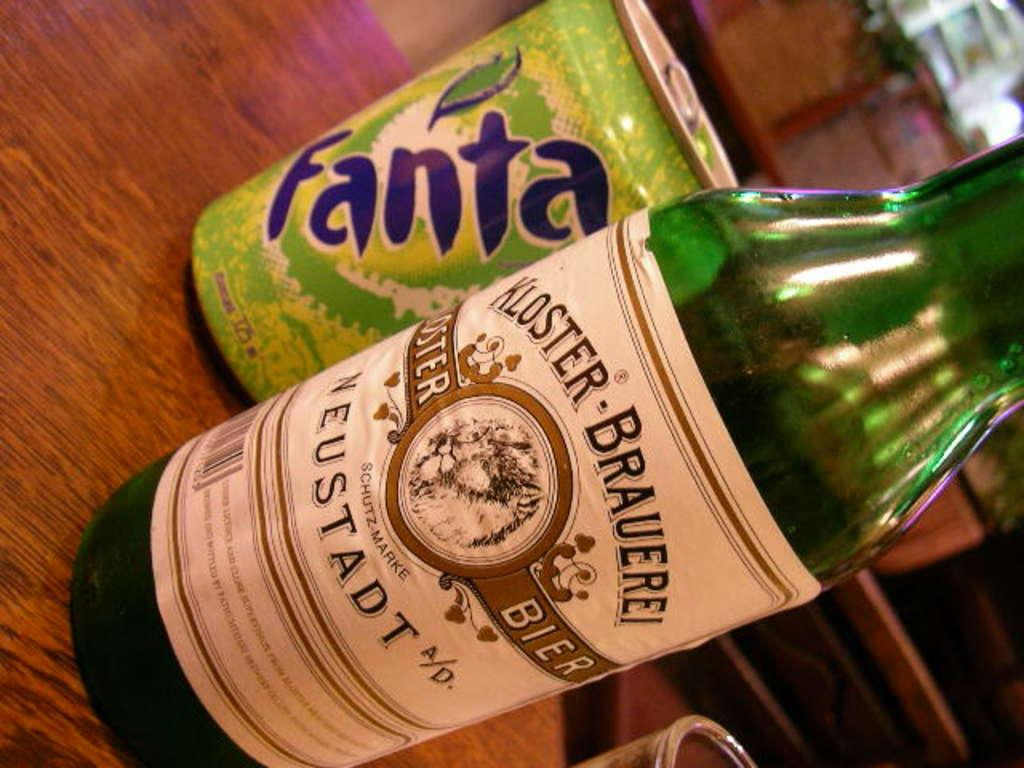<image>
Relay a brief, clear account of the picture shown. a bottle of kloster brauerei neustadt in front of apple fanta 